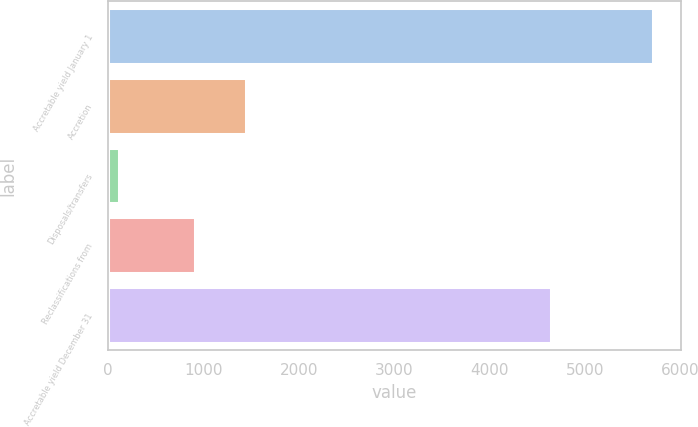Convert chart to OTSL. <chart><loc_0><loc_0><loc_500><loc_500><bar_chart><fcel>Accretable yield January 1<fcel>Accretion<fcel>Disposals/transfers<fcel>Reclassifications from<fcel>Accretable yield December 31<nl><fcel>5716.6<fcel>1448.3<fcel>118<fcel>912<fcel>4644<nl></chart> 